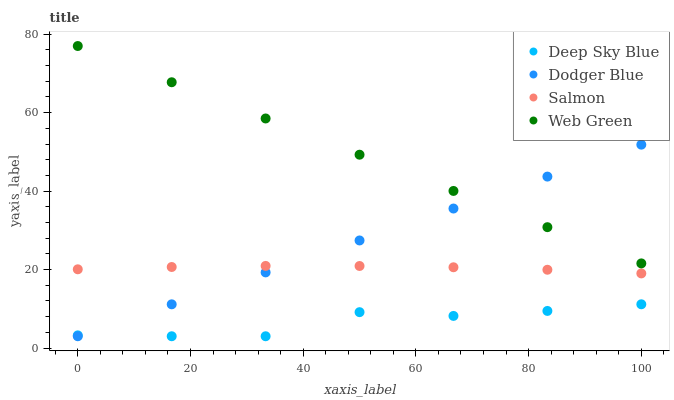Does Deep Sky Blue have the minimum area under the curve?
Answer yes or no. Yes. Does Web Green have the maximum area under the curve?
Answer yes or no. Yes. Does Dodger Blue have the minimum area under the curve?
Answer yes or no. No. Does Dodger Blue have the maximum area under the curve?
Answer yes or no. No. Is Dodger Blue the smoothest?
Answer yes or no. Yes. Is Deep Sky Blue the roughest?
Answer yes or no. Yes. Is Web Green the smoothest?
Answer yes or no. No. Is Web Green the roughest?
Answer yes or no. No. Does Dodger Blue have the lowest value?
Answer yes or no. Yes. Does Web Green have the lowest value?
Answer yes or no. No. Does Web Green have the highest value?
Answer yes or no. Yes. Does Dodger Blue have the highest value?
Answer yes or no. No. Is Deep Sky Blue less than Salmon?
Answer yes or no. Yes. Is Web Green greater than Salmon?
Answer yes or no. Yes. Does Deep Sky Blue intersect Dodger Blue?
Answer yes or no. Yes. Is Deep Sky Blue less than Dodger Blue?
Answer yes or no. No. Is Deep Sky Blue greater than Dodger Blue?
Answer yes or no. No. Does Deep Sky Blue intersect Salmon?
Answer yes or no. No. 